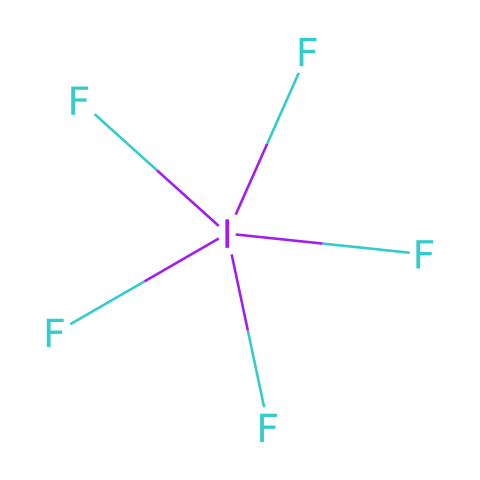What is the chemical formula of this compound? The chemical formula is determined by the number and type of atoms present in the structure. The structure shows one iodine (I) atom and five fluorine (F) atoms. Therefore, the chemical formula can be written as IF5.
Answer: IF5 How many fluorine atoms are present in this compound? The structure indicates that there are five fluorine atoms attached to the iodine atom. The count of fluorine symbols (F) in the structure confirms this number.
Answer: five What type of compound is iodine pentafluoride? Iodine pentafluoride is classified as a hypervalent compound because it has more than four bonds around the central iodine atom, thus exceeding the octet rule. This is characteristic of hypervalent species.
Answer: hypervalent How many bonds are formed between iodine and fluorine in this structure? The structure shows that iodine is bonded to five fluorine atoms. Each fluorine atom forms one bond with the iodine atom, leading to a total of five iodine-fluorine bonds.
Answer: five What is the oxidation state of iodine in iodine pentafluoride? The oxidation state of iodine can be calculated by considering that fluorine generally has an oxidation state of -1. With five fluorine atoms, the overall charge contributed is -5. Therefore, iodine must be in the +5 oxidation state to balance this.
Answer: +5 What is the hybridization of the iodine atom in this compound? To determine the hybridization, we note that iodine has five bonding pairs with fluorine and no lone pairs, leading to an sp3d hybridization. This accommodates the five bonds and gives a trigonal bipyramidal geometry.
Answer: sp3d What principal characteristic differentiates hypervalent compounds from other compounds? Hypervalent compounds, unlike others, can expand their valence shell to accommodate more than eight electrons due to the presence of d orbitals in elements from the third period and beyond. Iodine in IF5 exemplifies this characteristic.
Answer: expand valence shell 